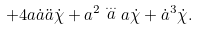<formula> <loc_0><loc_0><loc_500><loc_500>+ 4 a \dot { a } \ddot { a } \dot { \chi } + a ^ { 2 } \stackrel { \dots } { a } a \dot { \chi } + \dot { a } ^ { 3 } \dot { \chi } .</formula> 